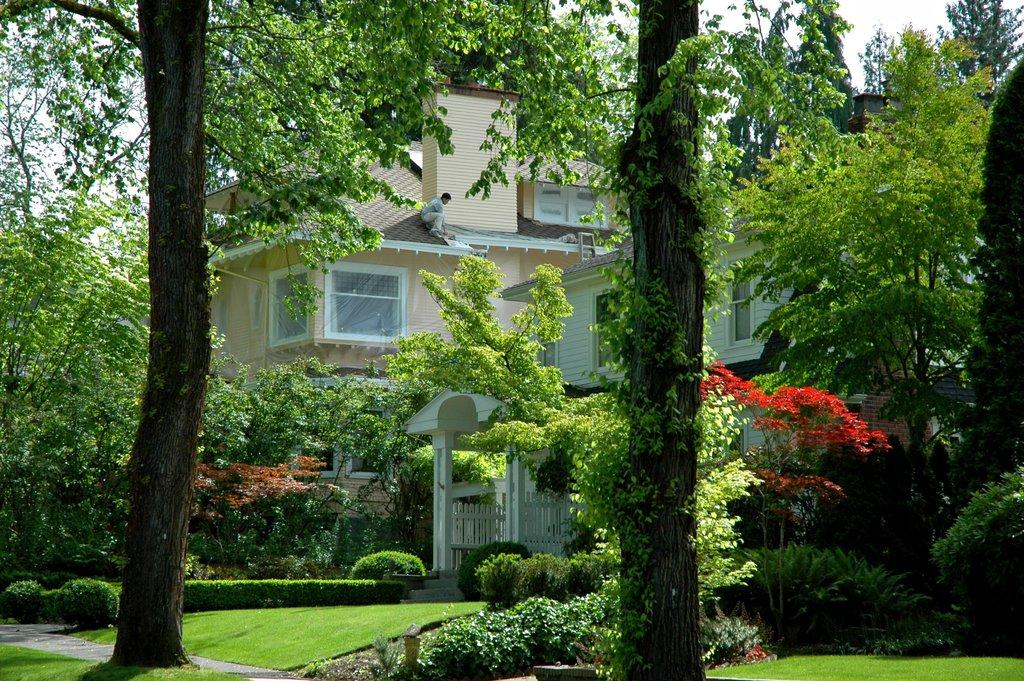What is the main feature in the center of the image? There are trees in the center of the image. What can be seen in the background of the image? There is a house in the background of the image. What type of vegetation is at the bottom of the image? There is grass at the bottom of the image. What language is spoken by the ray in the image? There is no ray present in the image, and therefore no language can be attributed to it. 